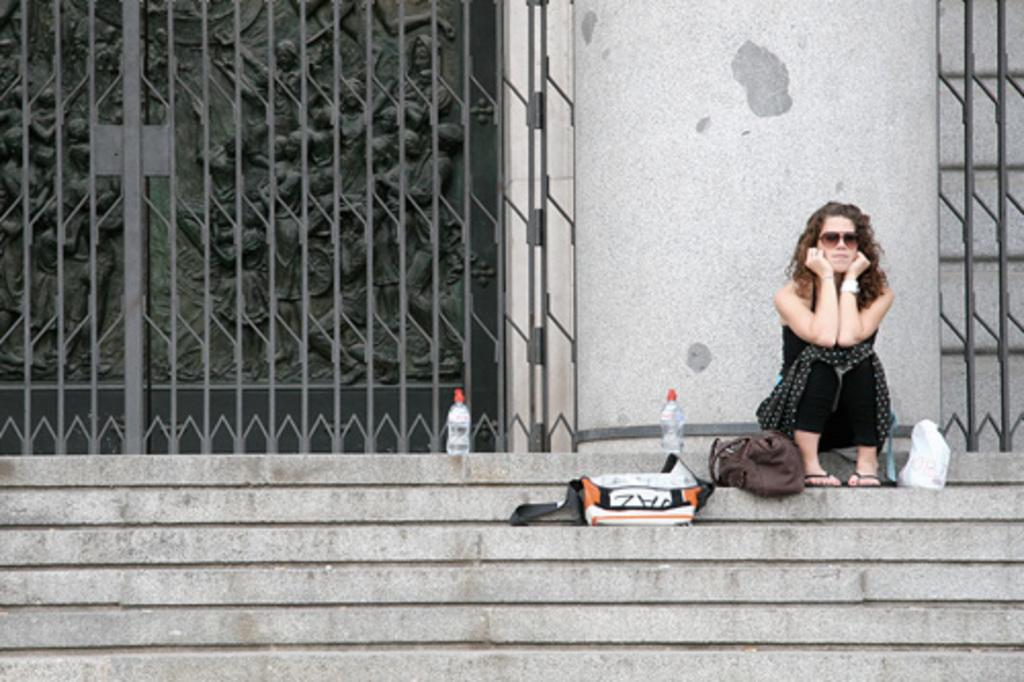What is the woman in the image doing? The woman is sitting on the steps. What else can be seen on the steps? Bottles and bags are present on the steps. What can be seen in the background of the image? There is a metal gate and a wall in the background, as well as sculptures visible on a platform. What type of grass is growing on the woman's head in the image? There is no grass visible on the woman's head in the image. Can you tell me how many quartz crystals are present on the steps? There is no mention of quartz crystals in the image; only bottles and bags are visible on the steps. 